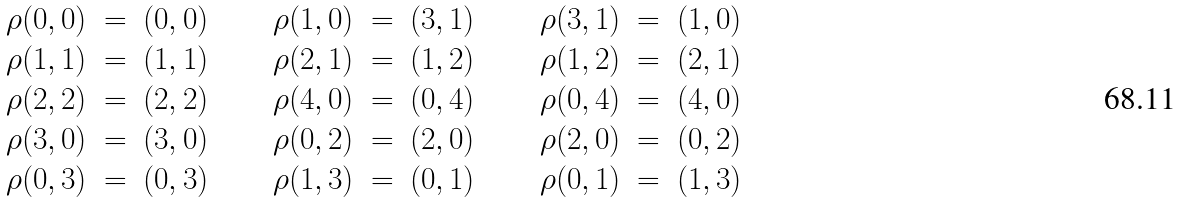Convert formula to latex. <formula><loc_0><loc_0><loc_500><loc_500>\begin{array} { r c l c r c l c r c l } \rho ( 0 , 0 ) & = & ( 0 , 0 ) & \quad & \rho ( 1 , 0 ) & = & ( 3 , 1 ) & \quad & \rho ( 3 , 1 ) & = & ( 1 , 0 ) \\ \rho ( 1 , 1 ) & = & ( 1 , 1 ) & & \rho ( 2 , 1 ) & = & ( 1 , 2 ) & & \rho ( 1 , 2 ) & = & ( 2 , 1 ) \\ \rho ( 2 , 2 ) & = & ( 2 , 2 ) & & \rho ( 4 , 0 ) & = & ( 0 , 4 ) & & \rho ( 0 , 4 ) & = & ( 4 , 0 ) \\ \rho ( 3 , 0 ) & = & ( 3 , 0 ) & & \rho ( 0 , 2 ) & = & ( 2 , 0 ) & & \rho ( 2 , 0 ) & = & ( 0 , 2 ) \\ \rho ( 0 , 3 ) & = & ( 0 , 3 ) & & \rho ( 1 , 3 ) & = & ( 0 , 1 ) & & \rho ( 0 , 1 ) & = & ( 1 , 3 ) \end{array}</formula> 